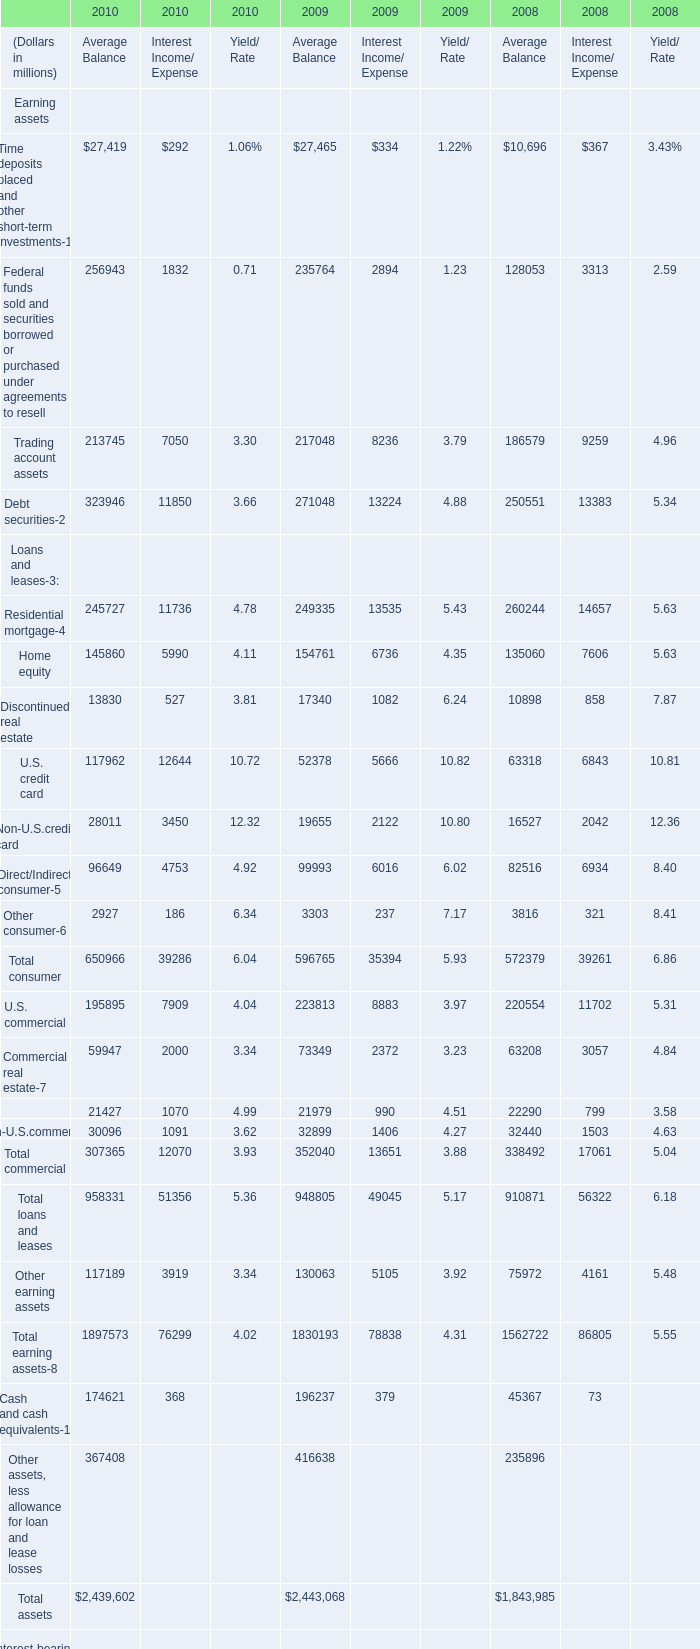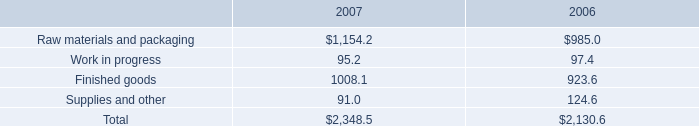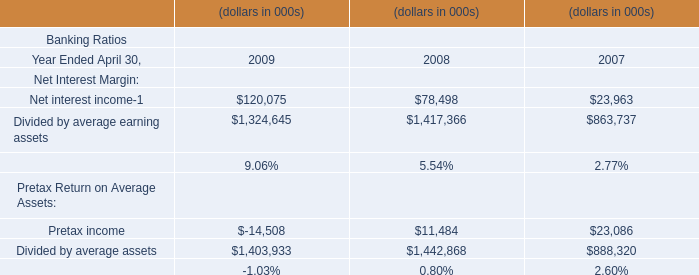What's the total amount of Time deposits placed and other short-term investments, Trading account assets, Debt securities and Residential mortgage in Average Balance in 2010? (in millions) 
Computations: (((27419 + 213745) + 323946) + 245727)
Answer: 810837.0. 